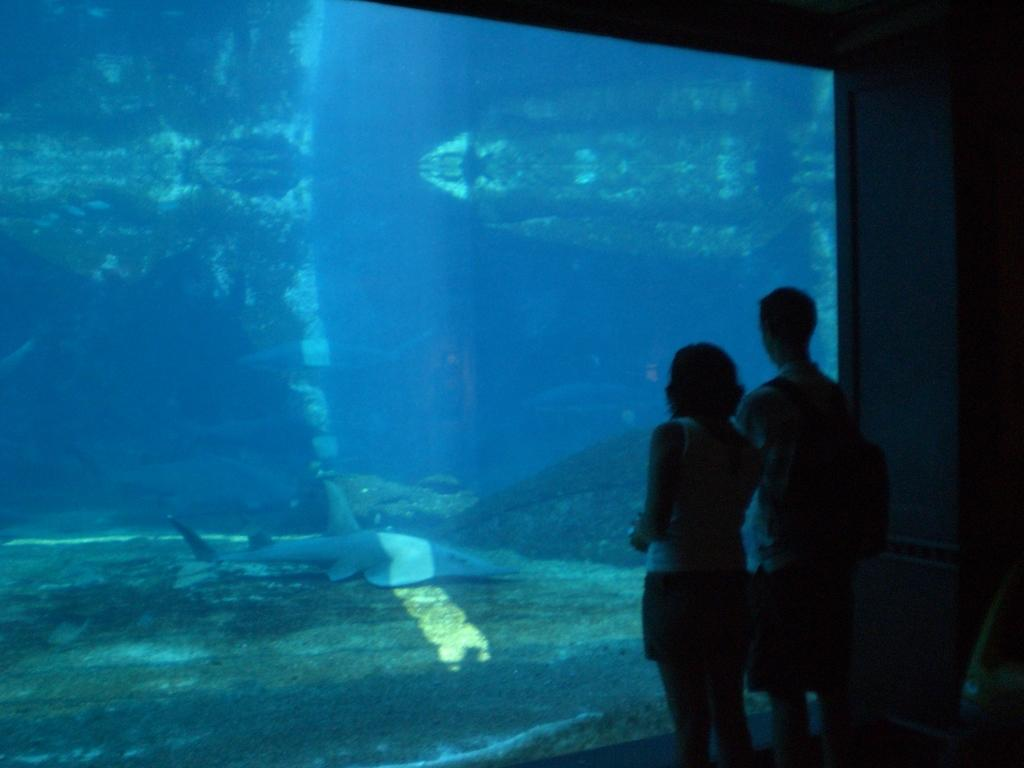How many people are present in the image? There are two persons standing in the image. What can be seen in the background of the image? There is an aquarium in the image. What type of animal is in the aquarium? There is a fish in the aquarium. What type of education is being offered in the image? There is no indication of any educational activity or offering in the image. 